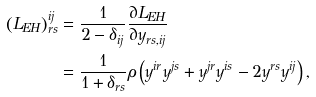Convert formula to latex. <formula><loc_0><loc_0><loc_500><loc_500>\left ( L _ { E H } \right ) _ { r s } ^ { i j } & = \frac { 1 } { 2 - \delta _ { i j } } \frac { \partial L _ { E H } } { \partial y _ { r s , i j } } \\ & = \frac { 1 } { 1 + \delta _ { r s } } \rho \left ( y ^ { i r } y ^ { j s } + y ^ { j r } y ^ { i s } - 2 y ^ { r s } y ^ { i j } \right ) ,</formula> 